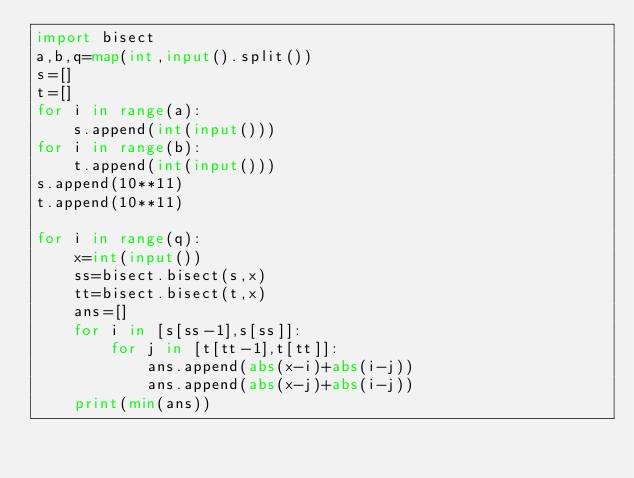Convert code to text. <code><loc_0><loc_0><loc_500><loc_500><_Python_>import bisect
a,b,q=map(int,input().split())
s=[]
t=[]
for i in range(a):
    s.append(int(input()))
for i in range(b):
    t.append(int(input()))
s.append(10**11)
t.append(10**11)

for i in range(q):
    x=int(input())
    ss=bisect.bisect(s,x)
    tt=bisect.bisect(t,x)
    ans=[]
    for i in [s[ss-1],s[ss]]:
        for j in [t[tt-1],t[tt]]:
            ans.append(abs(x-i)+abs(i-j))
            ans.append(abs(x-j)+abs(i-j))
    print(min(ans))
    
</code> 